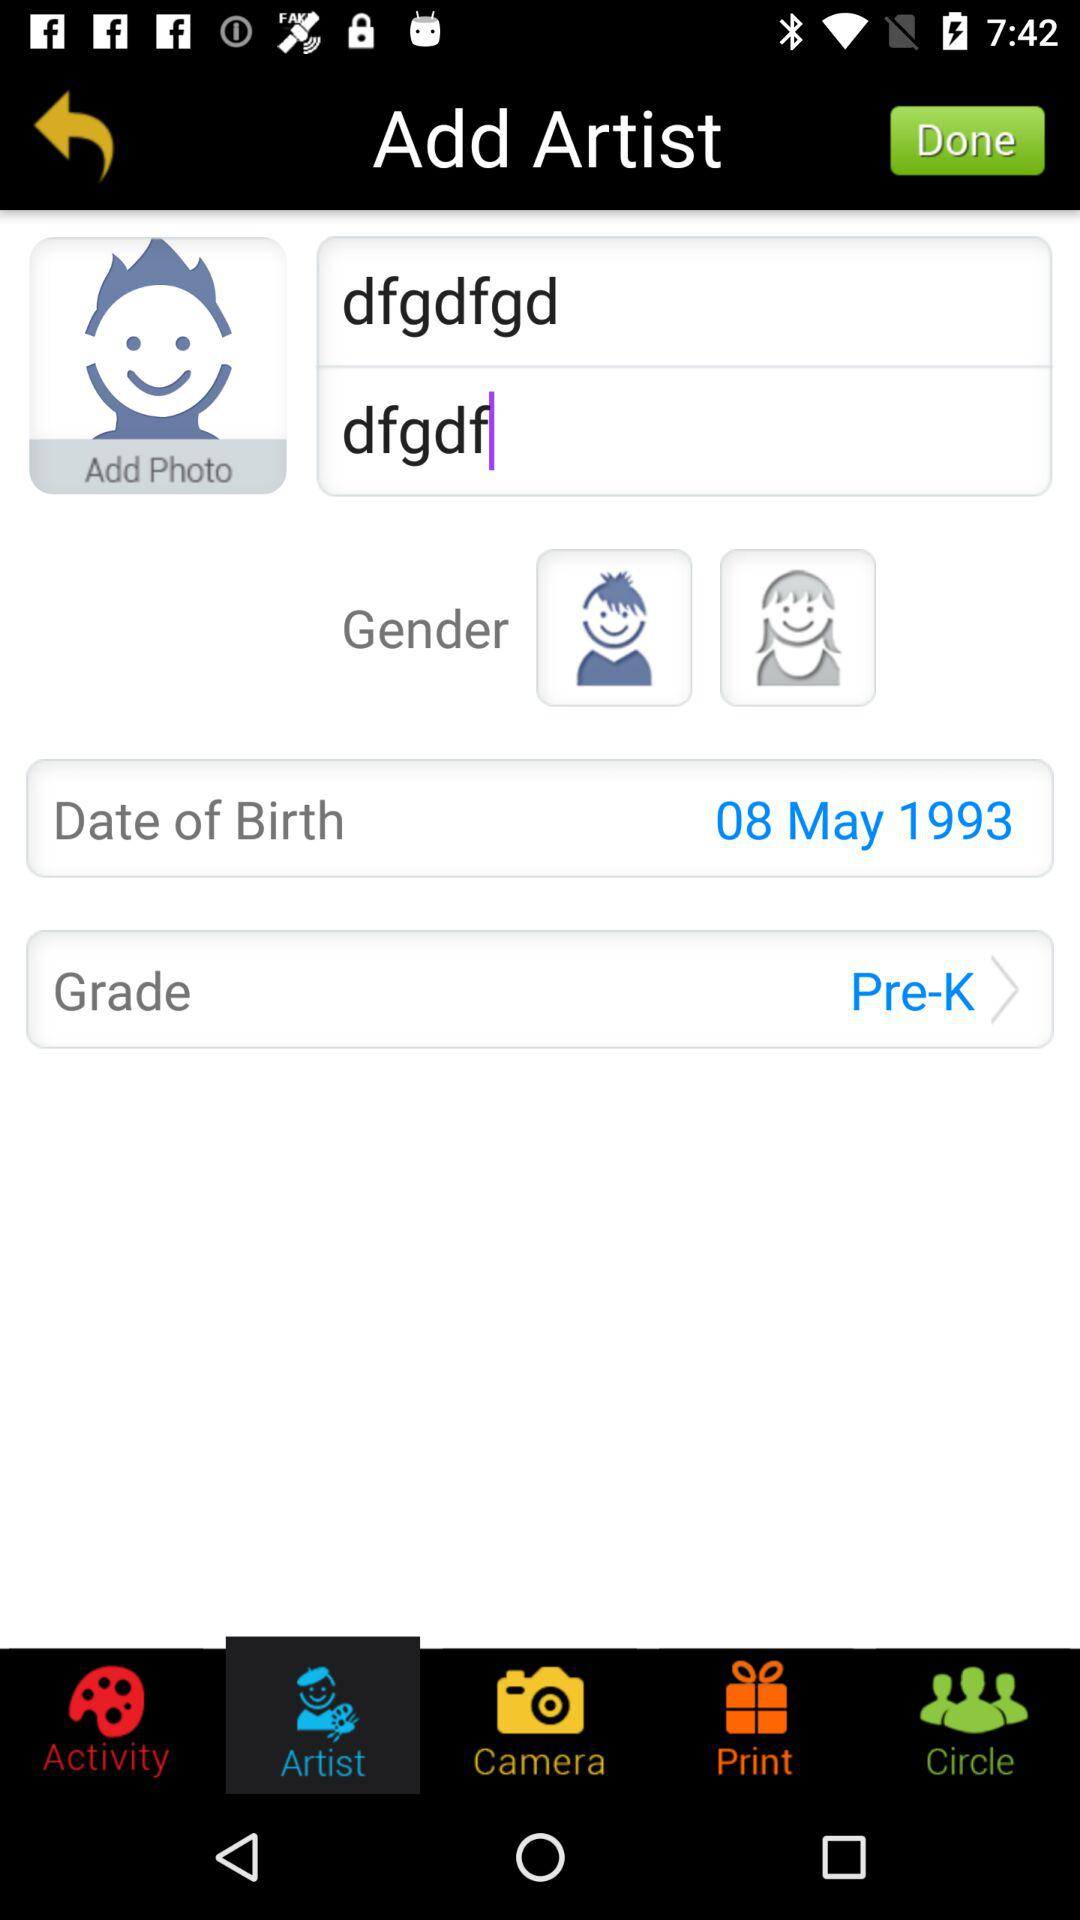How many notifications are there in "Circle"?
When the provided information is insufficient, respond with <no answer>. <no answer> 